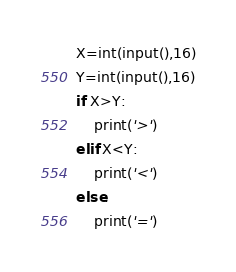<code> <loc_0><loc_0><loc_500><loc_500><_Python_>X=int(input(),16)
Y=int(input(),16)
if X>Y:
    print('>')
elif X<Y:
    print('<')
else:
    print('=')</code> 